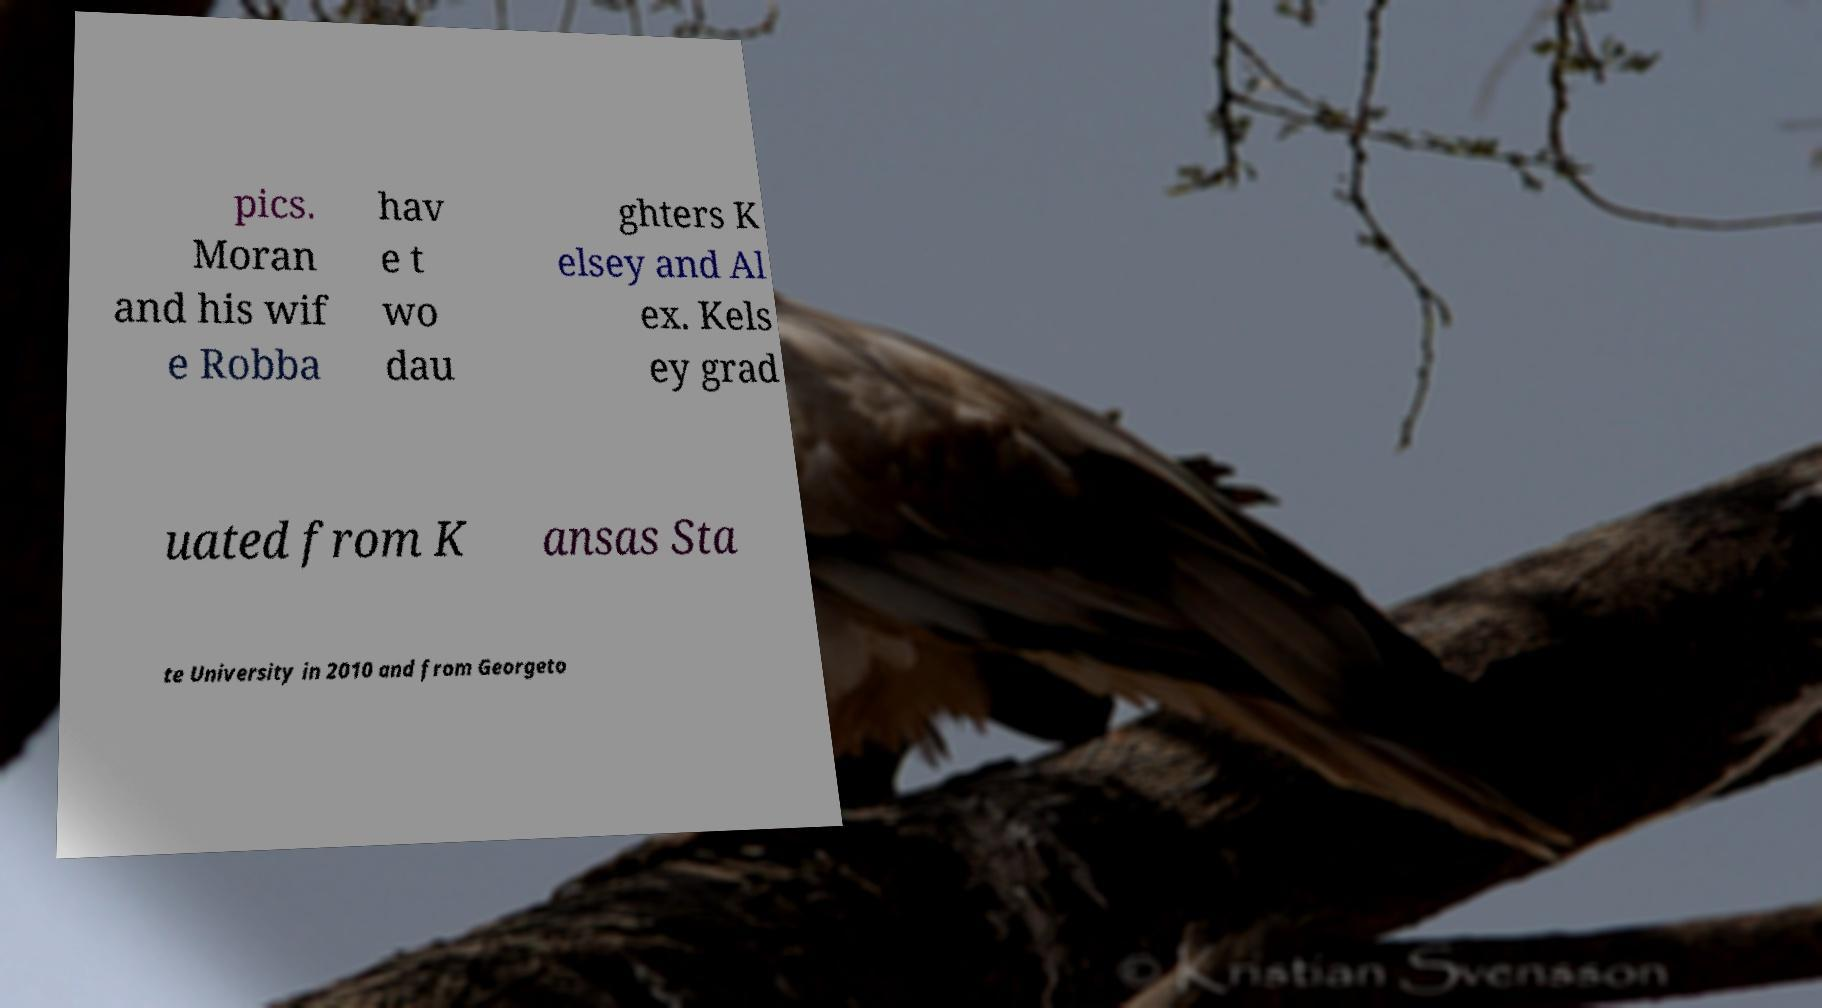Can you accurately transcribe the text from the provided image for me? pics. Moran and his wif e Robba hav e t wo dau ghters K elsey and Al ex. Kels ey grad uated from K ansas Sta te University in 2010 and from Georgeto 